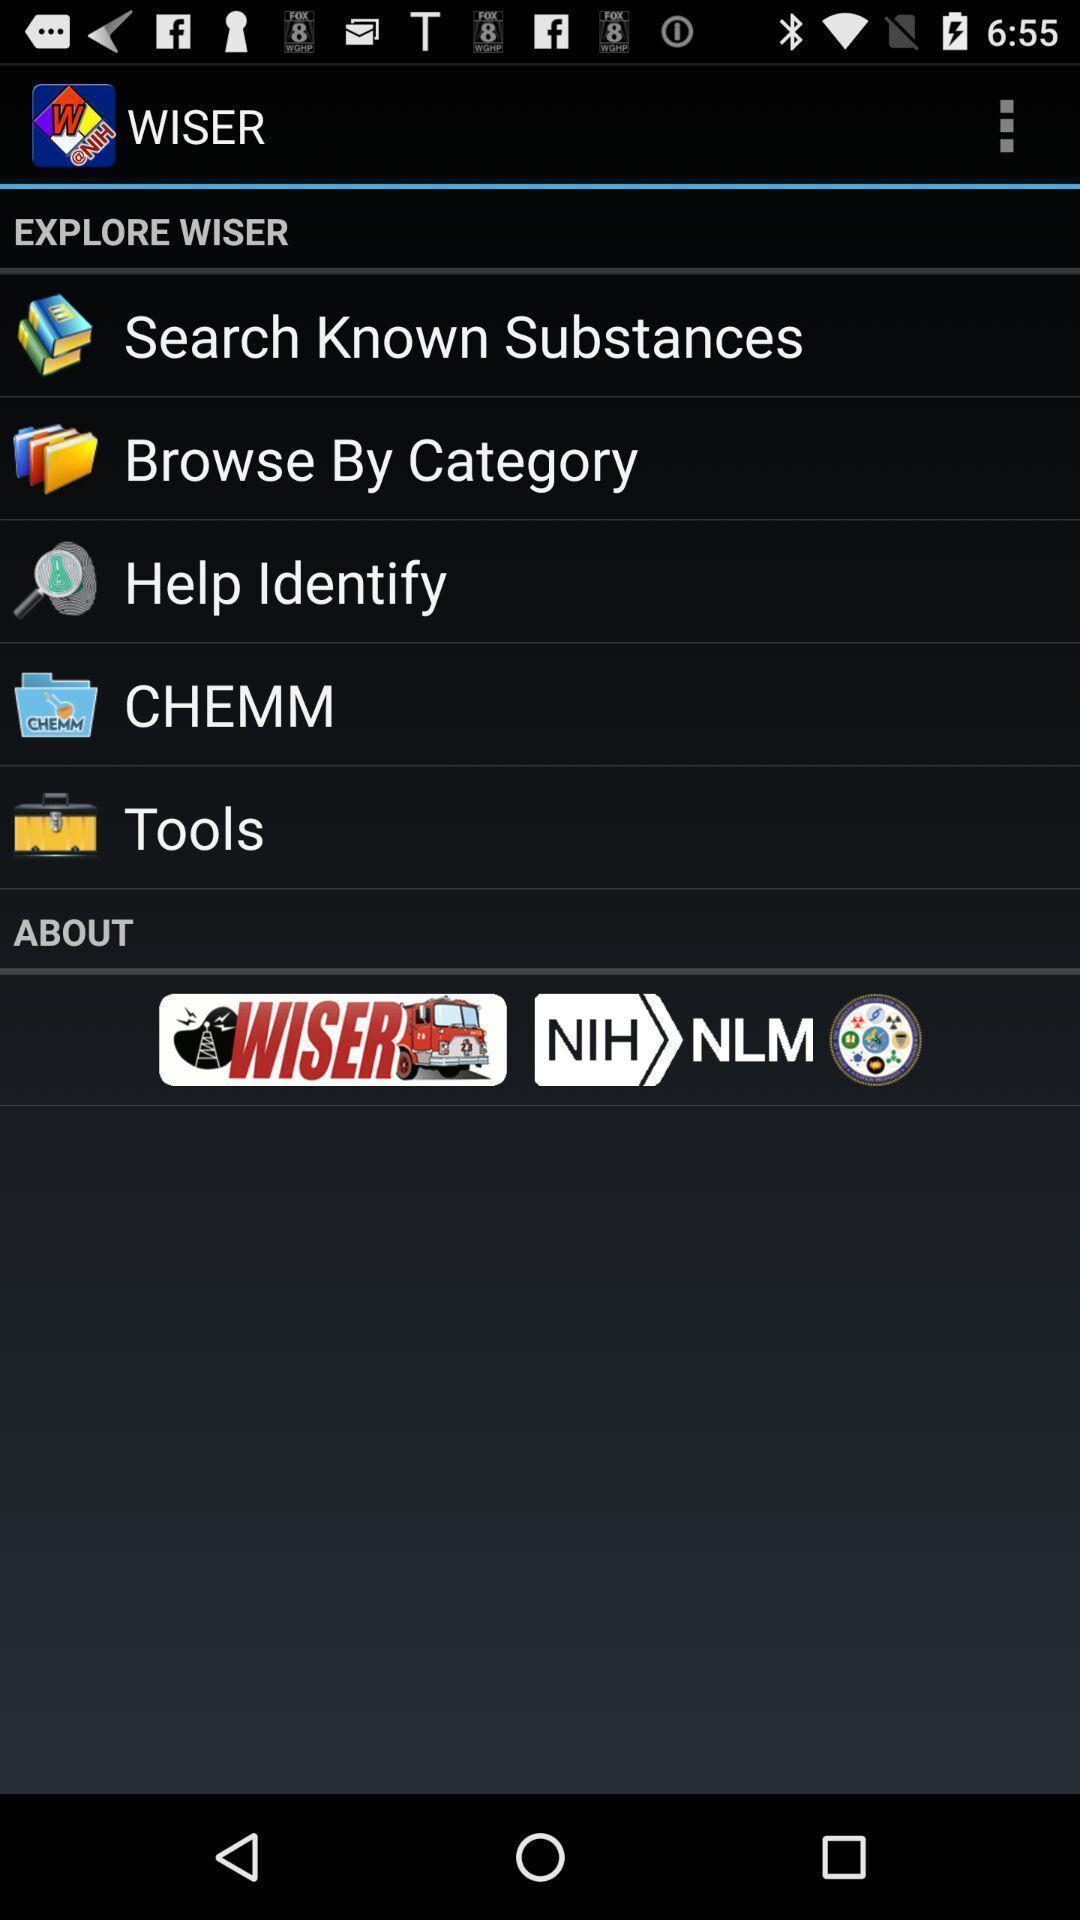Describe the content in this image. Screen displaying page. 